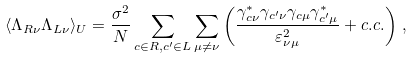<formula> <loc_0><loc_0><loc_500><loc_500>\langle \Lambda _ { R \nu } \Lambda _ { L \nu } \rangle _ { U } = \frac { \sigma ^ { 2 } } { N } \sum _ { c \in R , c ^ { \prime } \in L } \sum _ { \mu \ne \nu } \left ( \frac { \gamma _ { c \nu } ^ { \ast } \gamma _ { c ^ { \prime } \nu } \gamma _ { c \mu } \gamma _ { c ^ { \prime } \mu } ^ { \ast } } { \varepsilon _ { \nu \mu } ^ { 2 } } + c . c . \right ) \, ,</formula> 